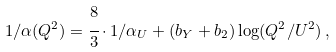<formula> <loc_0><loc_0><loc_500><loc_500>1 / \alpha ( Q ^ { 2 } ) = \cfrac { 8 } { 3 } \cdot 1 / \alpha _ { U } + ( { b _ { Y } } + { b _ { 2 } } ) \log ( { Q ^ { 2 } } / { U ^ { 2 } } ) \, ,</formula> 